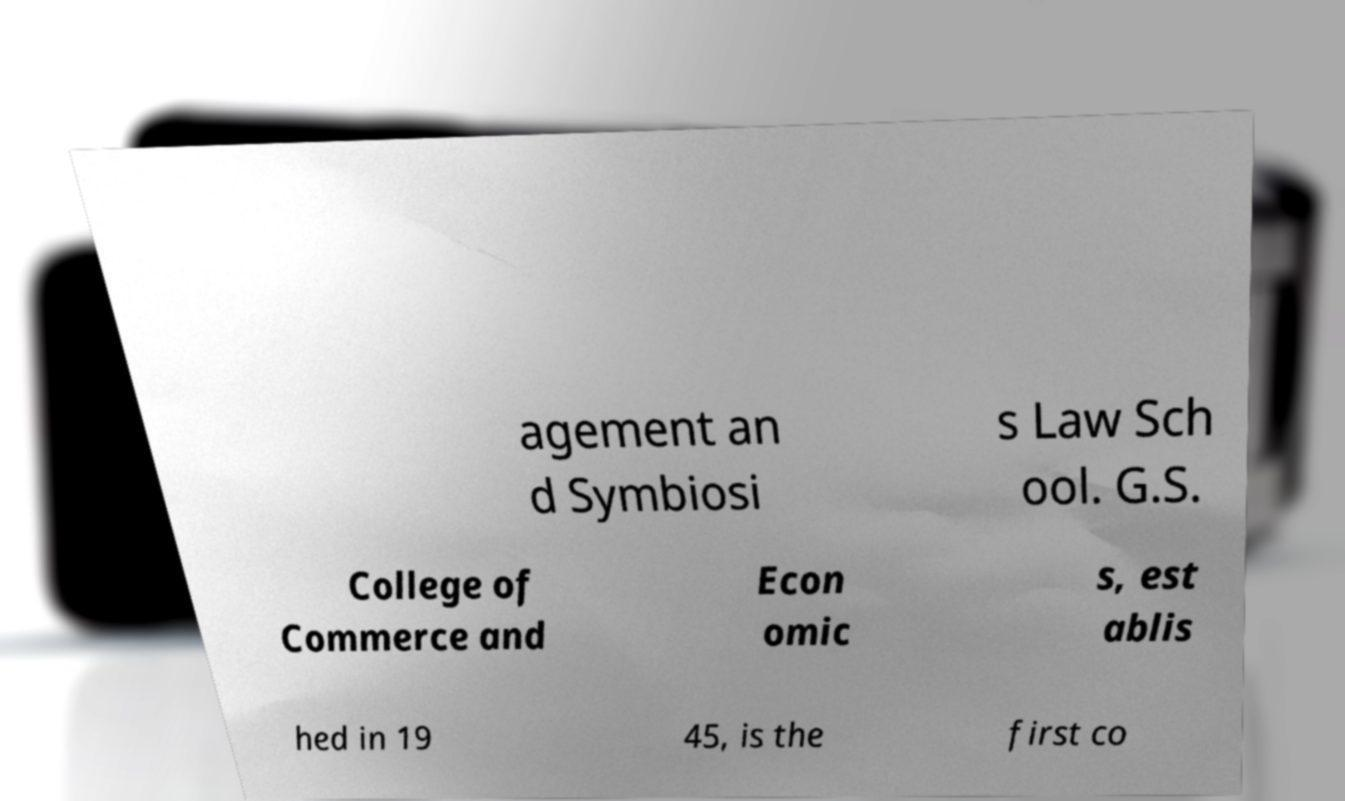Please identify and transcribe the text found in this image. agement an d Symbiosi s Law Sch ool. G.S. College of Commerce and Econ omic s, est ablis hed in 19 45, is the first co 